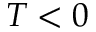<formula> <loc_0><loc_0><loc_500><loc_500>T < 0</formula> 